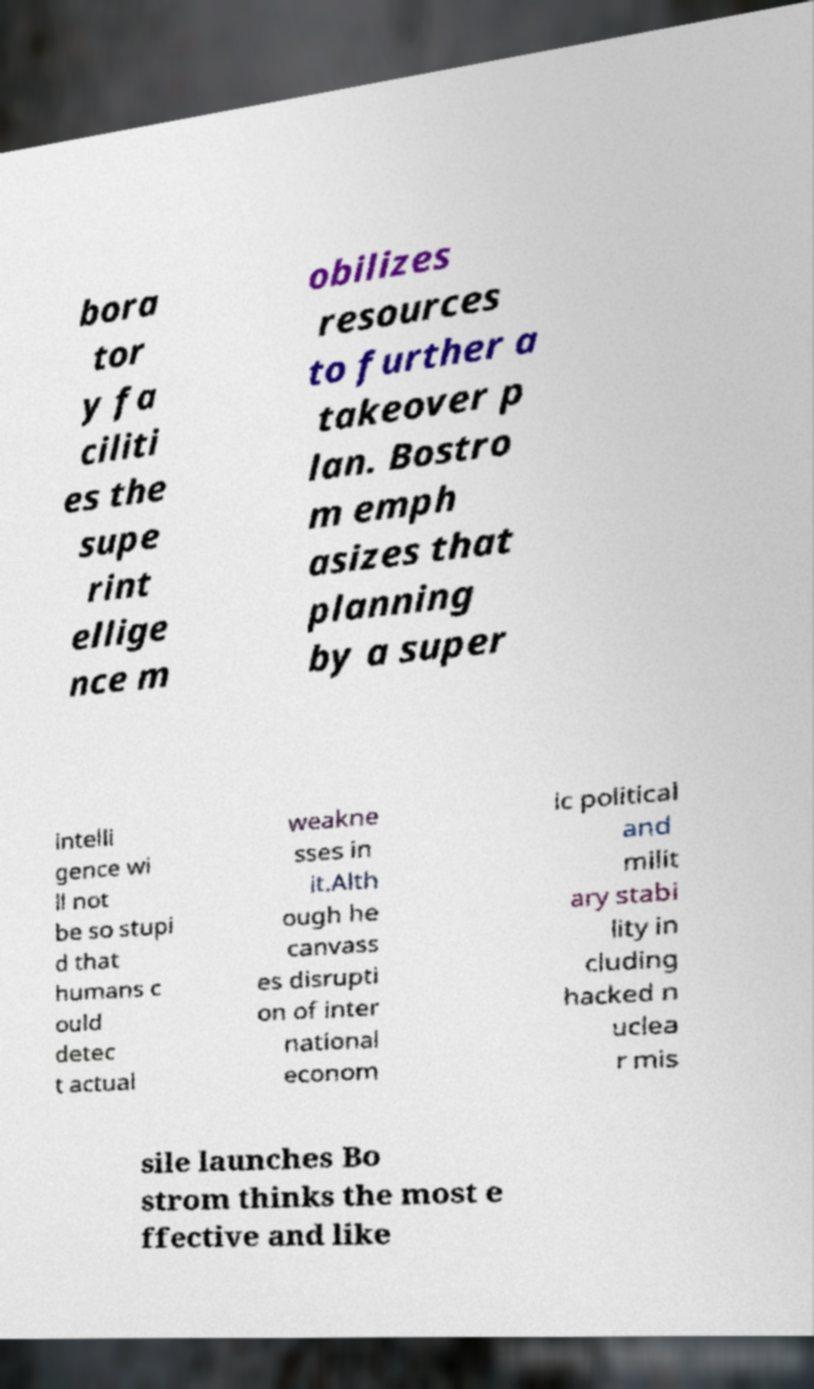Could you assist in decoding the text presented in this image and type it out clearly? bora tor y fa ciliti es the supe rint ellige nce m obilizes resources to further a takeover p lan. Bostro m emph asizes that planning by a super intelli gence wi ll not be so stupi d that humans c ould detec t actual weakne sses in it.Alth ough he canvass es disrupti on of inter national econom ic political and milit ary stabi lity in cluding hacked n uclea r mis sile launches Bo strom thinks the most e ffective and like 